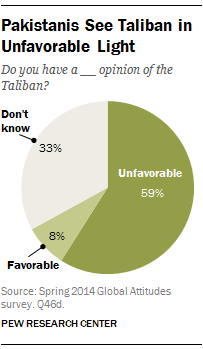Highlight a few significant elements in this photo. According to the data, 33% of the respondents selected the "Don't know" option. The sum of the percentage of those who found the favorable and those who did not have an opinion is 41%. 